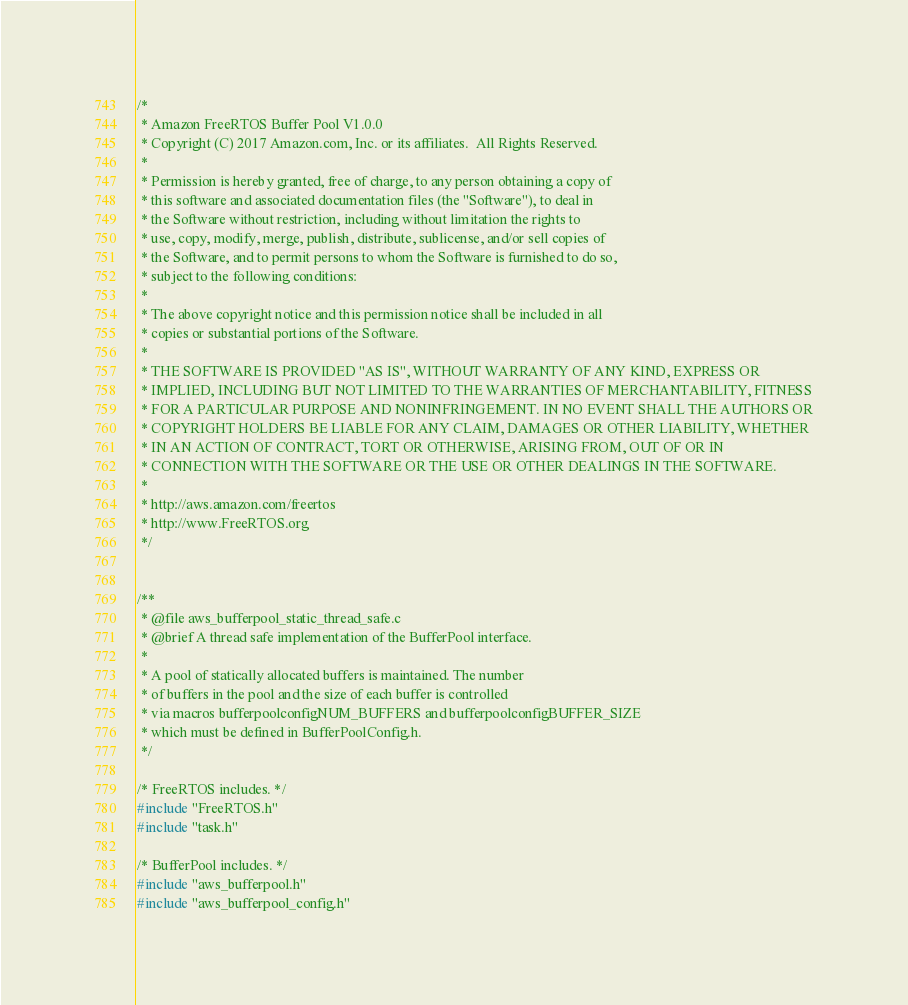<code> <loc_0><loc_0><loc_500><loc_500><_C_>/*
 * Amazon FreeRTOS Buffer Pool V1.0.0
 * Copyright (C) 2017 Amazon.com, Inc. or its affiliates.  All Rights Reserved.
 *
 * Permission is hereby granted, free of charge, to any person obtaining a copy of
 * this software and associated documentation files (the "Software"), to deal in
 * the Software without restriction, including without limitation the rights to
 * use, copy, modify, merge, publish, distribute, sublicense, and/or sell copies of
 * the Software, and to permit persons to whom the Software is furnished to do so,
 * subject to the following conditions:
 *
 * The above copyright notice and this permission notice shall be included in all
 * copies or substantial portions of the Software.
 *
 * THE SOFTWARE IS PROVIDED "AS IS", WITHOUT WARRANTY OF ANY KIND, EXPRESS OR
 * IMPLIED, INCLUDING BUT NOT LIMITED TO THE WARRANTIES OF MERCHANTABILITY, FITNESS
 * FOR A PARTICULAR PURPOSE AND NONINFRINGEMENT. IN NO EVENT SHALL THE AUTHORS OR
 * COPYRIGHT HOLDERS BE LIABLE FOR ANY CLAIM, DAMAGES OR OTHER LIABILITY, WHETHER
 * IN AN ACTION OF CONTRACT, TORT OR OTHERWISE, ARISING FROM, OUT OF OR IN
 * CONNECTION WITH THE SOFTWARE OR THE USE OR OTHER DEALINGS IN THE SOFTWARE.
 *
 * http://aws.amazon.com/freertos
 * http://www.FreeRTOS.org
 */


/**
 * @file aws_bufferpool_static_thread_safe.c
 * @brief A thread safe implementation of the BufferPool interface.
 *
 * A pool of statically allocated buffers is maintained. The number
 * of buffers in the pool and the size of each buffer is controlled
 * via macros bufferpoolconfigNUM_BUFFERS and bufferpoolconfigBUFFER_SIZE
 * which must be defined in BufferPoolConfig.h.
 */

/* FreeRTOS includes. */
#include "FreeRTOS.h"
#include "task.h"

/* BufferPool includes. */
#include "aws_bufferpool.h"
#include "aws_bufferpool_config.h"
</code> 